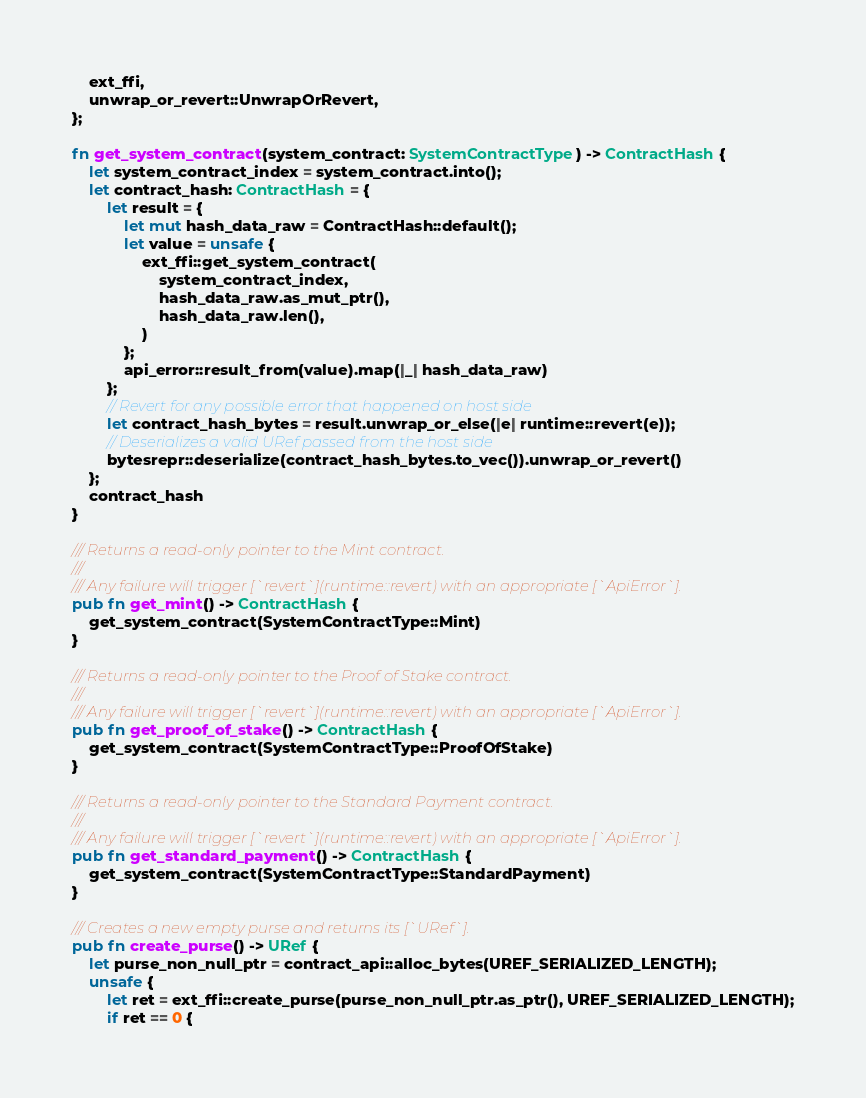<code> <loc_0><loc_0><loc_500><loc_500><_Rust_>    ext_ffi,
    unwrap_or_revert::UnwrapOrRevert,
};

fn get_system_contract(system_contract: SystemContractType) -> ContractHash {
    let system_contract_index = system_contract.into();
    let contract_hash: ContractHash = {
        let result = {
            let mut hash_data_raw = ContractHash::default();
            let value = unsafe {
                ext_ffi::get_system_contract(
                    system_contract_index,
                    hash_data_raw.as_mut_ptr(),
                    hash_data_raw.len(),
                )
            };
            api_error::result_from(value).map(|_| hash_data_raw)
        };
        // Revert for any possible error that happened on host side
        let contract_hash_bytes = result.unwrap_or_else(|e| runtime::revert(e));
        // Deserializes a valid URef passed from the host side
        bytesrepr::deserialize(contract_hash_bytes.to_vec()).unwrap_or_revert()
    };
    contract_hash
}

/// Returns a read-only pointer to the Mint contract.
///
/// Any failure will trigger [`revert`](runtime::revert) with an appropriate [`ApiError`].
pub fn get_mint() -> ContractHash {
    get_system_contract(SystemContractType::Mint)
}

/// Returns a read-only pointer to the Proof of Stake contract.
///
/// Any failure will trigger [`revert`](runtime::revert) with an appropriate [`ApiError`].
pub fn get_proof_of_stake() -> ContractHash {
    get_system_contract(SystemContractType::ProofOfStake)
}

/// Returns a read-only pointer to the Standard Payment contract.
///
/// Any failure will trigger [`revert`](runtime::revert) with an appropriate [`ApiError`].
pub fn get_standard_payment() -> ContractHash {
    get_system_contract(SystemContractType::StandardPayment)
}

/// Creates a new empty purse and returns its [`URef`].
pub fn create_purse() -> URef {
    let purse_non_null_ptr = contract_api::alloc_bytes(UREF_SERIALIZED_LENGTH);
    unsafe {
        let ret = ext_ffi::create_purse(purse_non_null_ptr.as_ptr(), UREF_SERIALIZED_LENGTH);
        if ret == 0 {</code> 